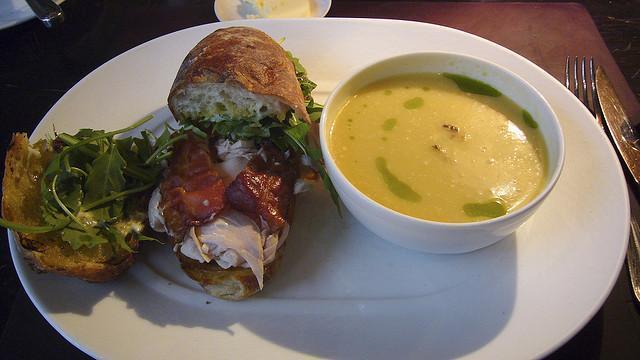How many sandwiches are there?
Give a very brief answer. 2. How many people have their hair down?
Give a very brief answer. 0. 